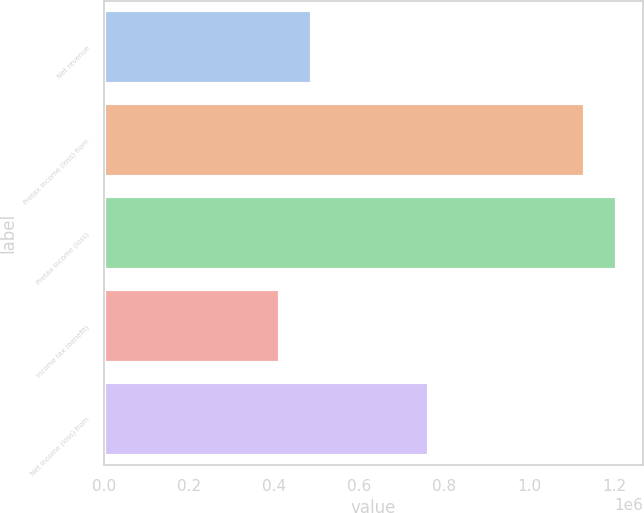<chart> <loc_0><loc_0><loc_500><loc_500><bar_chart><fcel>Net revenue<fcel>Pretax income (loss) from<fcel>Pretax income (loss)<fcel>Income tax (benefit)<fcel>Net income (loss) from<nl><fcel>489065<fcel>1.13037e+06<fcel>1.20668e+06<fcel>412753<fcel>763123<nl></chart> 